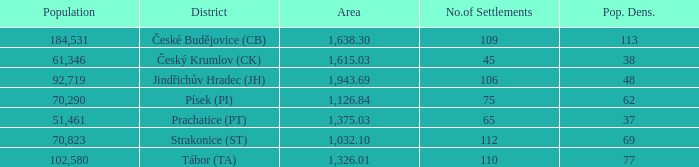Write the full table. {'header': ['Population', 'District', 'Area', 'No.of Settlements', 'Pop. Dens.'], 'rows': [['184,531', 'České Budějovice (CB)', '1,638.30', '109', '113'], ['61,346', 'Český Krumlov (CK)', '1,615.03', '45', '38'], ['92,719', 'Jindřichův Hradec (JH)', '1,943.69', '106', '48'], ['70,290', 'Písek (PI)', '1,126.84', '75', '62'], ['51,461', 'Prachatice (PT)', '1,375.03', '65', '37'], ['70,823', 'Strakonice (ST)', '1,032.10', '112', '69'], ['102,580', 'Tábor (TA)', '1,326.01', '110', '77']]} How big is the area that has a population density of 113 and a population larger than 184,531? 0.0. 